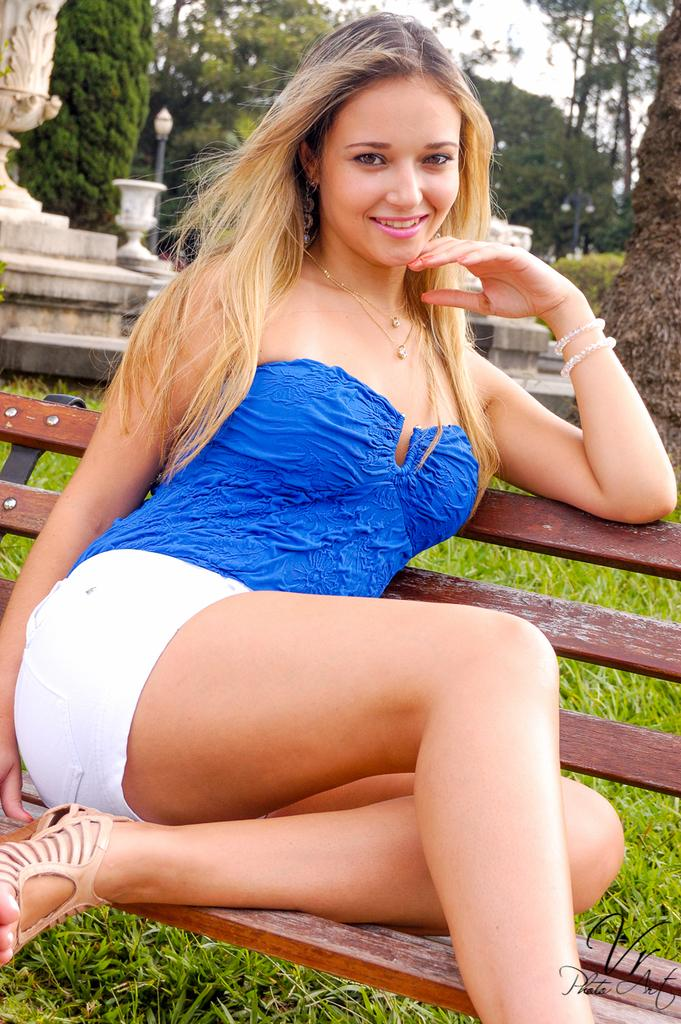Who is present in the image? There is a woman in the image. What is the woman wearing? The woman is wearing a blue and white dress. Where is the woman sitting? The woman is sitting on a bench. What type of natural environment is visible in the image? There is grass and trees visible in the image. What is the tall, vertical object in the image? There is a pole in the image. What can be seen in the background of the image? The sky is visible in the background of the image. What type of fuel is being used by the carriage in the image? There is no carriage present in the image, so it is not possible to determine what type of fuel might be used. 